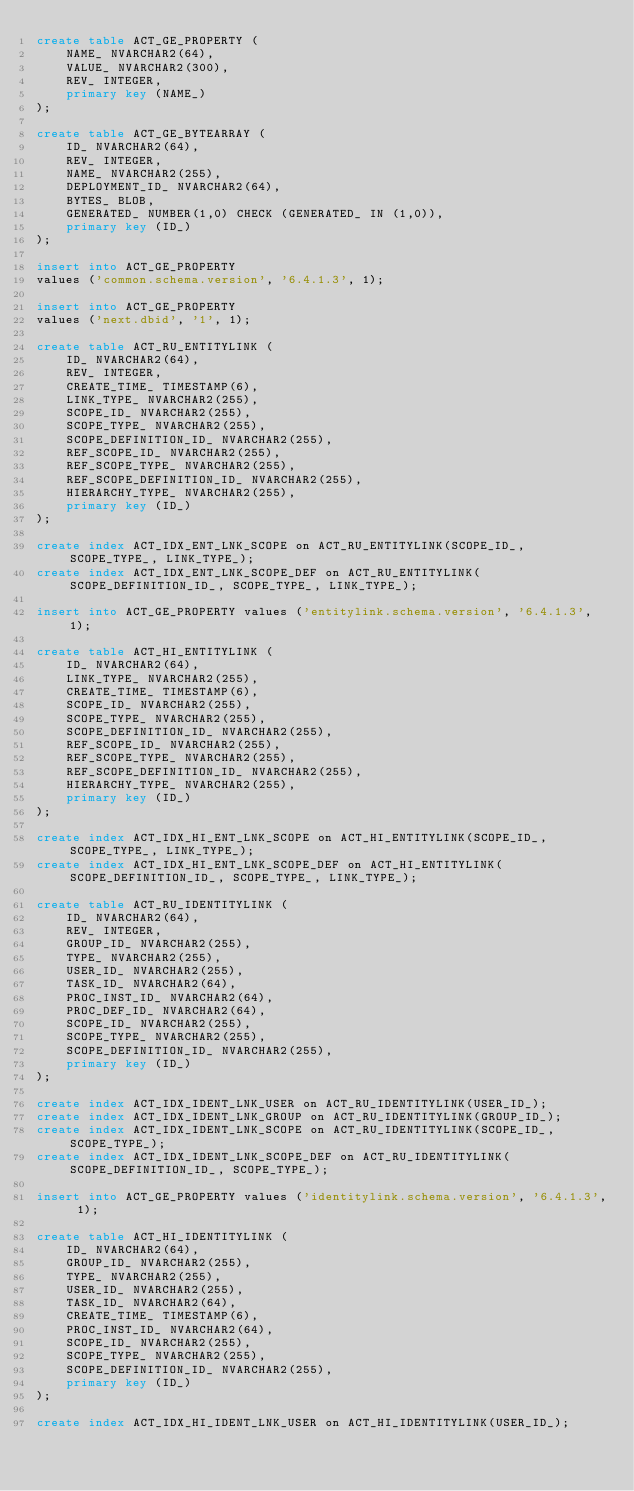Convert code to text. <code><loc_0><loc_0><loc_500><loc_500><_SQL_>create table ACT_GE_PROPERTY (
    NAME_ NVARCHAR2(64),
    VALUE_ NVARCHAR2(300),
    REV_ INTEGER,
    primary key (NAME_)
);

create table ACT_GE_BYTEARRAY (
    ID_ NVARCHAR2(64),
    REV_ INTEGER,
    NAME_ NVARCHAR2(255),
    DEPLOYMENT_ID_ NVARCHAR2(64),
    BYTES_ BLOB,
    GENERATED_ NUMBER(1,0) CHECK (GENERATED_ IN (1,0)),
    primary key (ID_)
);

insert into ACT_GE_PROPERTY
values ('common.schema.version', '6.4.1.3', 1);

insert into ACT_GE_PROPERTY
values ('next.dbid', '1', 1);

create table ACT_RU_ENTITYLINK (
    ID_ NVARCHAR2(64),
    REV_ INTEGER,
    CREATE_TIME_ TIMESTAMP(6),
    LINK_TYPE_ NVARCHAR2(255),
    SCOPE_ID_ NVARCHAR2(255),
    SCOPE_TYPE_ NVARCHAR2(255),
    SCOPE_DEFINITION_ID_ NVARCHAR2(255),
    REF_SCOPE_ID_ NVARCHAR2(255),
    REF_SCOPE_TYPE_ NVARCHAR2(255),
    REF_SCOPE_DEFINITION_ID_ NVARCHAR2(255),
    HIERARCHY_TYPE_ NVARCHAR2(255),
    primary key (ID_)
);

create index ACT_IDX_ENT_LNK_SCOPE on ACT_RU_ENTITYLINK(SCOPE_ID_, SCOPE_TYPE_, LINK_TYPE_);
create index ACT_IDX_ENT_LNK_SCOPE_DEF on ACT_RU_ENTITYLINK(SCOPE_DEFINITION_ID_, SCOPE_TYPE_, LINK_TYPE_);

insert into ACT_GE_PROPERTY values ('entitylink.schema.version', '6.4.1.3', 1);

create table ACT_HI_ENTITYLINK (
    ID_ NVARCHAR2(64),
    LINK_TYPE_ NVARCHAR2(255),
    CREATE_TIME_ TIMESTAMP(6),
    SCOPE_ID_ NVARCHAR2(255),
    SCOPE_TYPE_ NVARCHAR2(255),
    SCOPE_DEFINITION_ID_ NVARCHAR2(255),
    REF_SCOPE_ID_ NVARCHAR2(255),
    REF_SCOPE_TYPE_ NVARCHAR2(255),
    REF_SCOPE_DEFINITION_ID_ NVARCHAR2(255),
    HIERARCHY_TYPE_ NVARCHAR2(255),
    primary key (ID_)
);

create index ACT_IDX_HI_ENT_LNK_SCOPE on ACT_HI_ENTITYLINK(SCOPE_ID_, SCOPE_TYPE_, LINK_TYPE_);
create index ACT_IDX_HI_ENT_LNK_SCOPE_DEF on ACT_HI_ENTITYLINK(SCOPE_DEFINITION_ID_, SCOPE_TYPE_, LINK_TYPE_);

create table ACT_RU_IDENTITYLINK (
    ID_ NVARCHAR2(64),
    REV_ INTEGER,
    GROUP_ID_ NVARCHAR2(255),
    TYPE_ NVARCHAR2(255),
    USER_ID_ NVARCHAR2(255),
    TASK_ID_ NVARCHAR2(64),
    PROC_INST_ID_ NVARCHAR2(64),
    PROC_DEF_ID_ NVARCHAR2(64),
    SCOPE_ID_ NVARCHAR2(255),
    SCOPE_TYPE_ NVARCHAR2(255),
    SCOPE_DEFINITION_ID_ NVARCHAR2(255),
    primary key (ID_)
);

create index ACT_IDX_IDENT_LNK_USER on ACT_RU_IDENTITYLINK(USER_ID_);
create index ACT_IDX_IDENT_LNK_GROUP on ACT_RU_IDENTITYLINK(GROUP_ID_);
create index ACT_IDX_IDENT_LNK_SCOPE on ACT_RU_IDENTITYLINK(SCOPE_ID_, SCOPE_TYPE_);
create index ACT_IDX_IDENT_LNK_SCOPE_DEF on ACT_RU_IDENTITYLINK(SCOPE_DEFINITION_ID_, SCOPE_TYPE_);

insert into ACT_GE_PROPERTY values ('identitylink.schema.version', '6.4.1.3', 1);

create table ACT_HI_IDENTITYLINK (
    ID_ NVARCHAR2(64),
    GROUP_ID_ NVARCHAR2(255),
    TYPE_ NVARCHAR2(255),
    USER_ID_ NVARCHAR2(255),
    TASK_ID_ NVARCHAR2(64),
    CREATE_TIME_ TIMESTAMP(6),
    PROC_INST_ID_ NVARCHAR2(64),
    SCOPE_ID_ NVARCHAR2(255),
    SCOPE_TYPE_ NVARCHAR2(255),
    SCOPE_DEFINITION_ID_ NVARCHAR2(255),
    primary key (ID_)
);

create index ACT_IDX_HI_IDENT_LNK_USER on ACT_HI_IDENTITYLINK(USER_ID_);</code> 